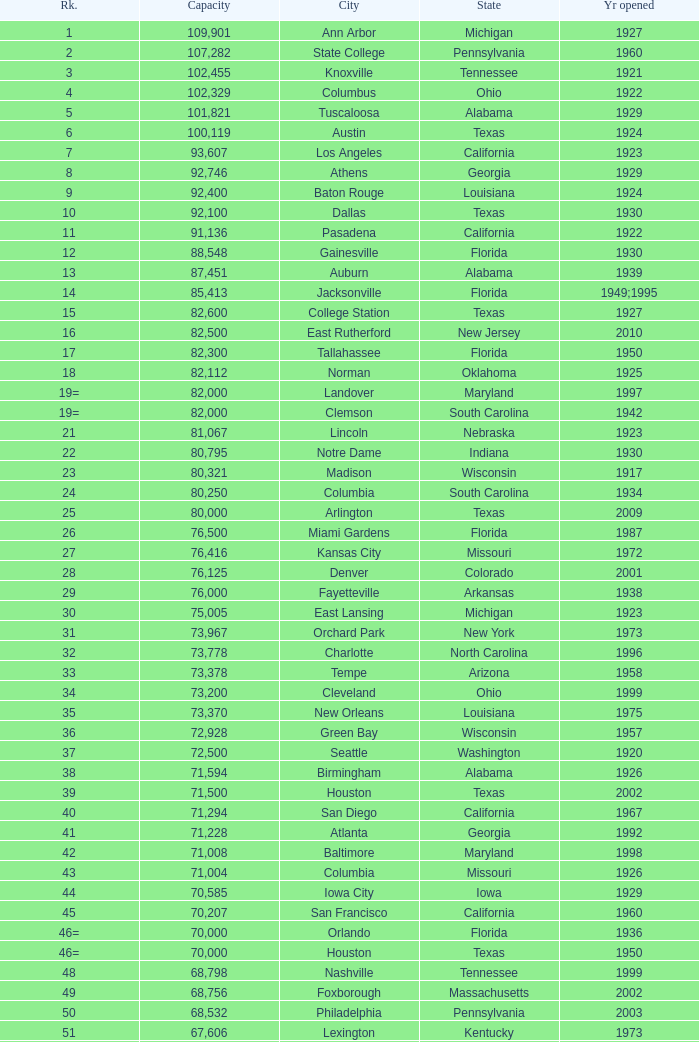What is the city in Alabama that opened in 1996? Huntsville. 